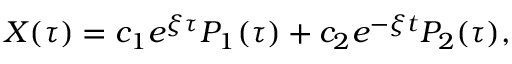Convert formula to latex. <formula><loc_0><loc_0><loc_500><loc_500>X ( \tau ) = c _ { 1 } e ^ { \xi \tau } P _ { 1 } ( \tau ) + c _ { 2 } e ^ { - \xi t } P _ { 2 } ( \tau ) ,</formula> 